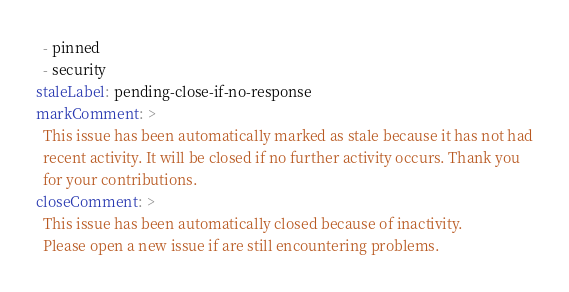Convert code to text. <code><loc_0><loc_0><loc_500><loc_500><_YAML_>  - pinned
  - security
staleLabel: pending-close-if-no-response
markComment: >
  This issue has been automatically marked as stale because it has not had
  recent activity. It will be closed if no further activity occurs. Thank you
  for your contributions.
closeComment: >
  This issue has been automatically closed because of inactivity.
  Please open a new issue if are still encountering problems.
</code> 